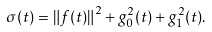<formula> <loc_0><loc_0><loc_500><loc_500>\sigma ( t ) = \left \| f ( t ) \right \| ^ { 2 } + g _ { 0 } ^ { 2 } ( t ) + g _ { 1 } ^ { 2 } ( t ) .</formula> 